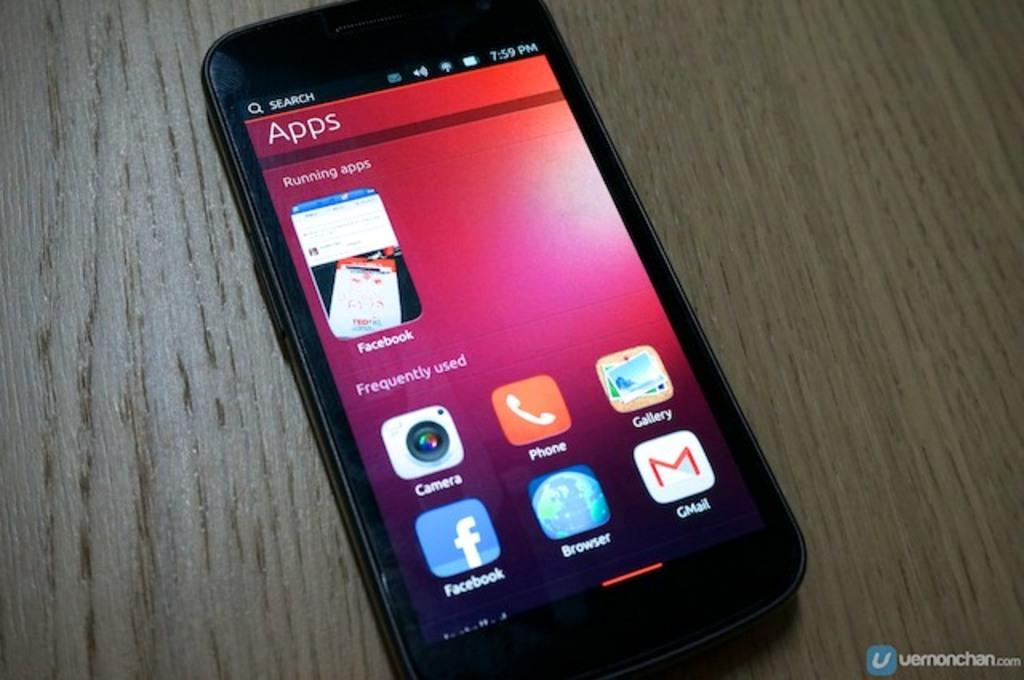<image>
Describe the image concisely. a phone that says 'search' on the top black bar of the screen 